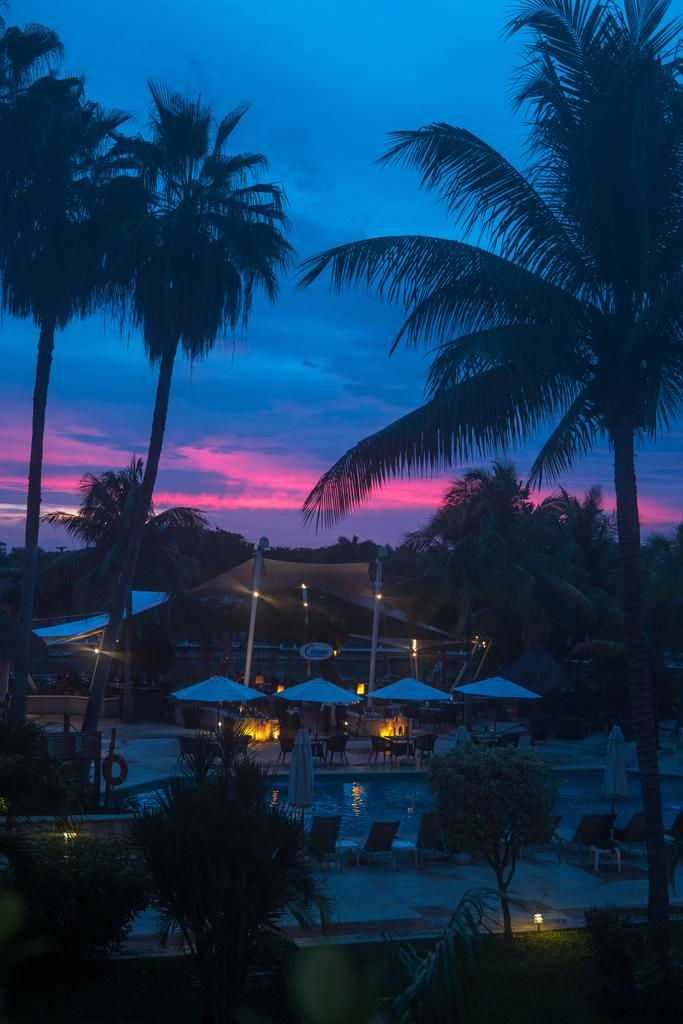What type of structures can be seen in the image? There are sheds in the image. What type of furniture is present in the image? There are chairs and tables in the image. What type of lighting is present in the image? There are light poles in the image. What type of vegetation is present in the image? There are plants and trees in the image. What can be seen in the background of the image? The sky is visible in the background of the image. What type of loaf can be seen on the sidewalk in the image? There is no loaf or sidewalk present in the image. What type of alley can be seen behind the sheds in the image? There is no alley present in the image; only sheds, chairs, tables, light poles, plants, trees, and the sky are visible. 